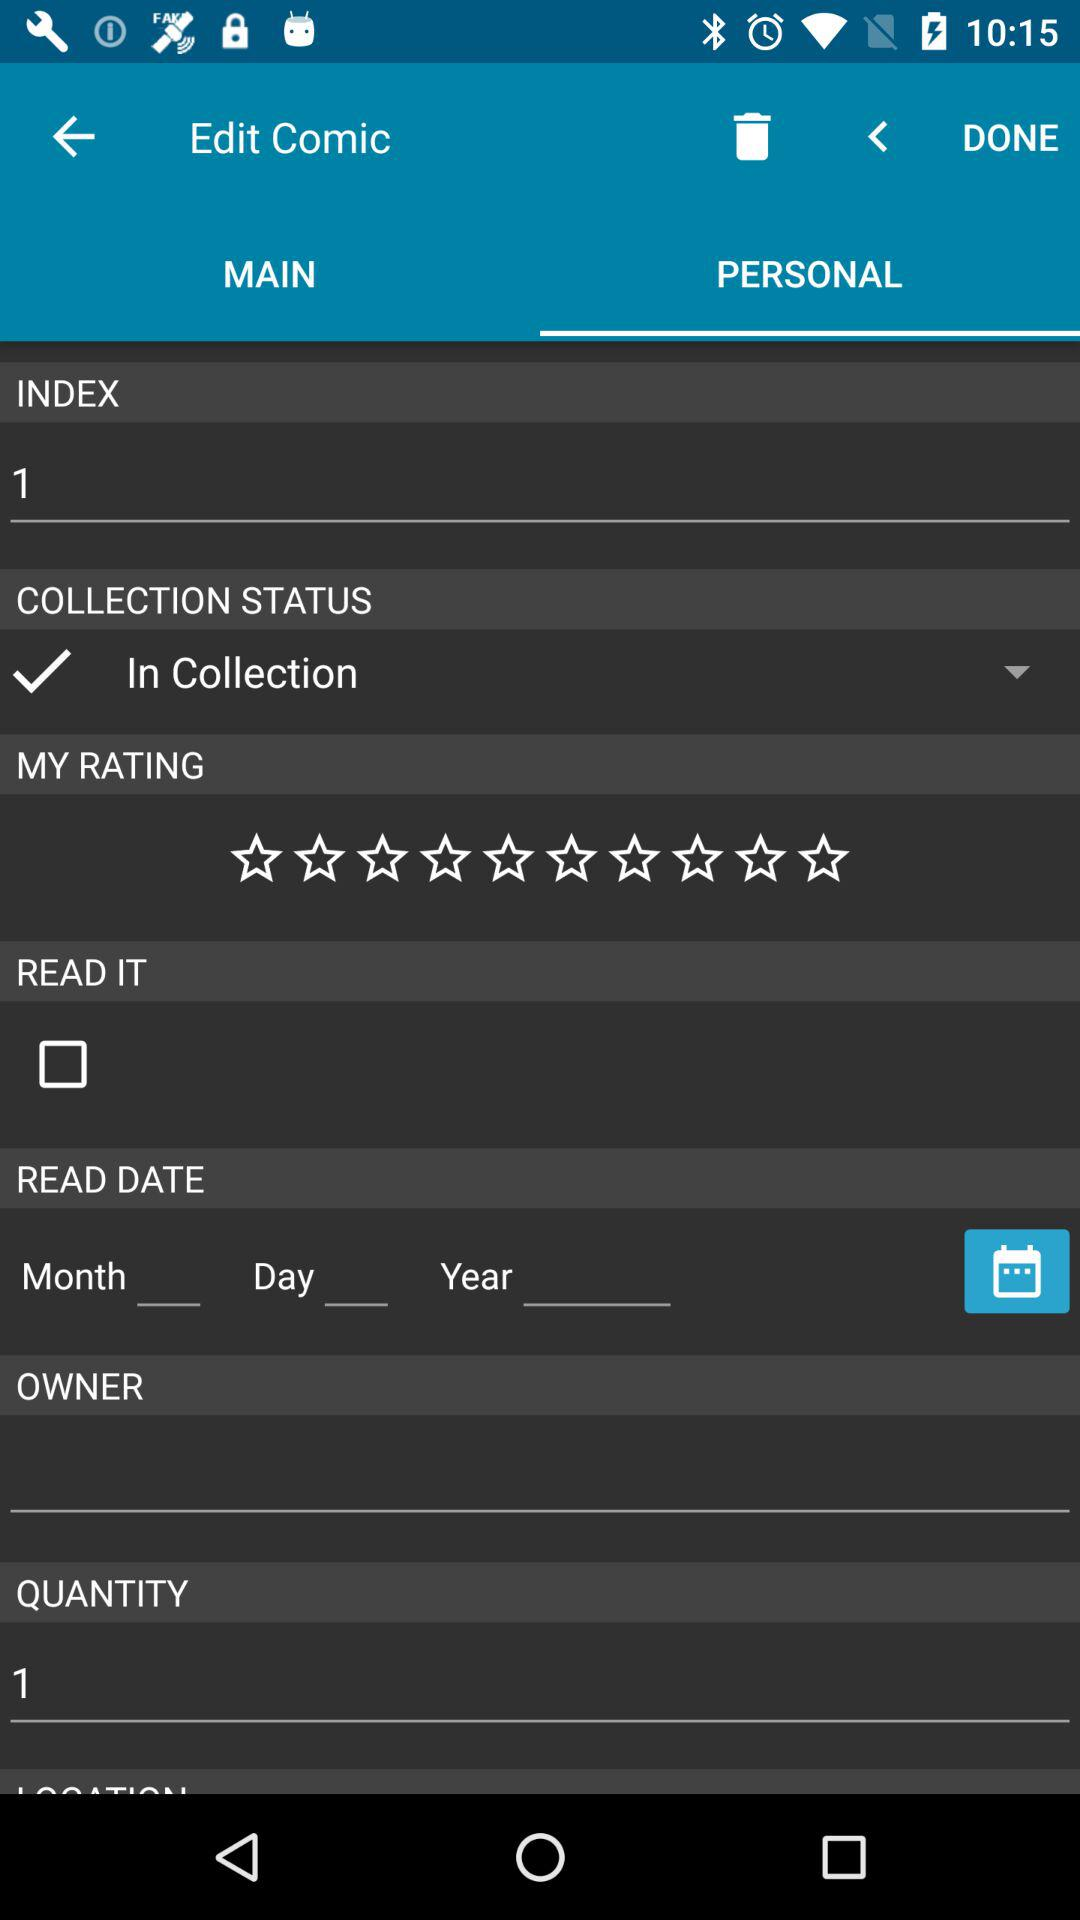What is the total count of quantities? The total count is 1. 